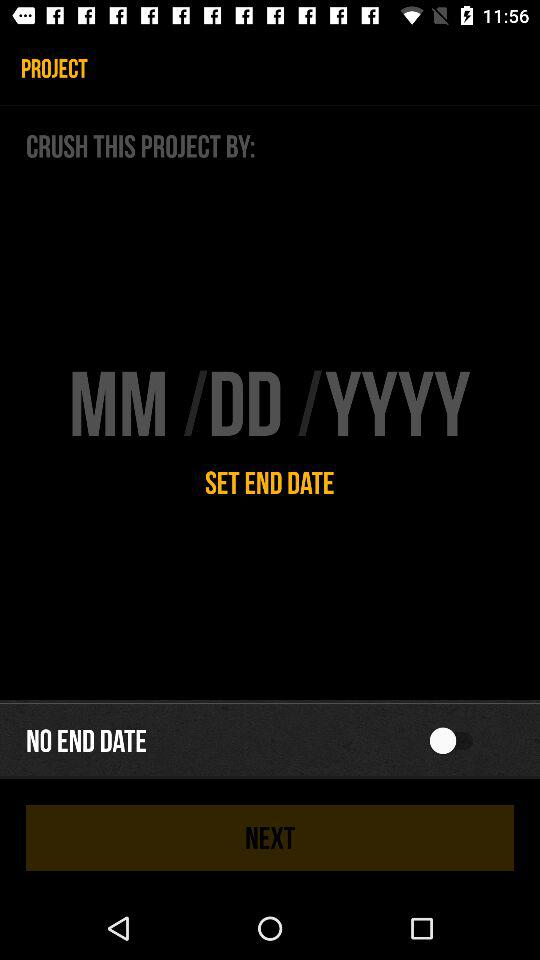Is there any end date? There is no end date. 